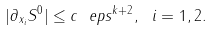Convert formula to latex. <formula><loc_0><loc_0><loc_500><loc_500>| \partial _ { x _ { i } } S ^ { 0 } | \leq c \ e p s ^ { k + 2 } , \ i = 1 , 2 .</formula> 